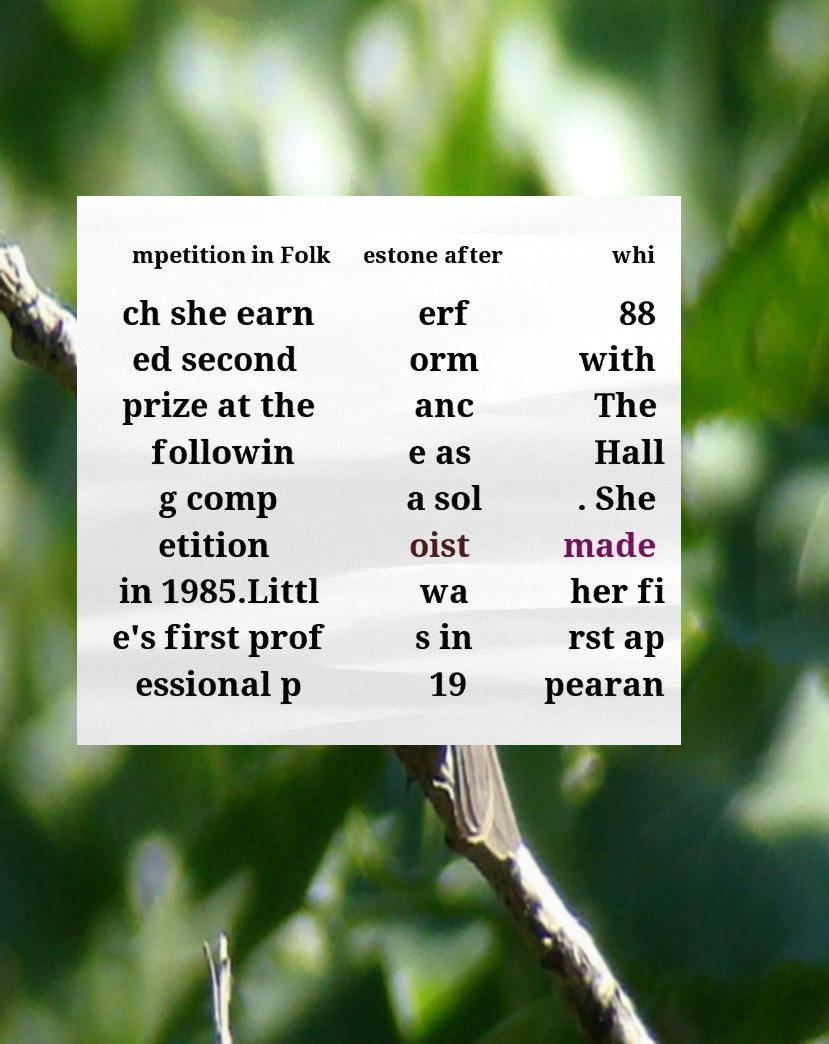Please identify and transcribe the text found in this image. mpetition in Folk estone after whi ch she earn ed second prize at the followin g comp etition in 1985.Littl e's first prof essional p erf orm anc e as a sol oist wa s in 19 88 with The Hall . She made her fi rst ap pearan 